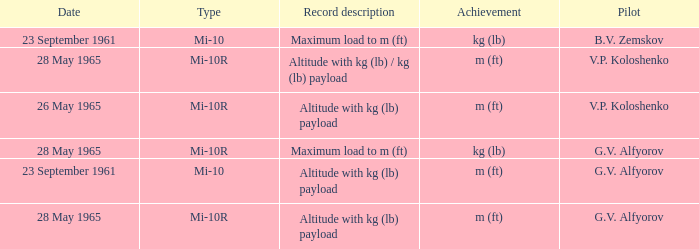Achievement of m (ft), and a Type of mi-10r, and a Pilot of v.p. koloshenko, and a Date of 28 may 1965 had what record description? Altitude with kg (lb) / kg (lb) payload. 